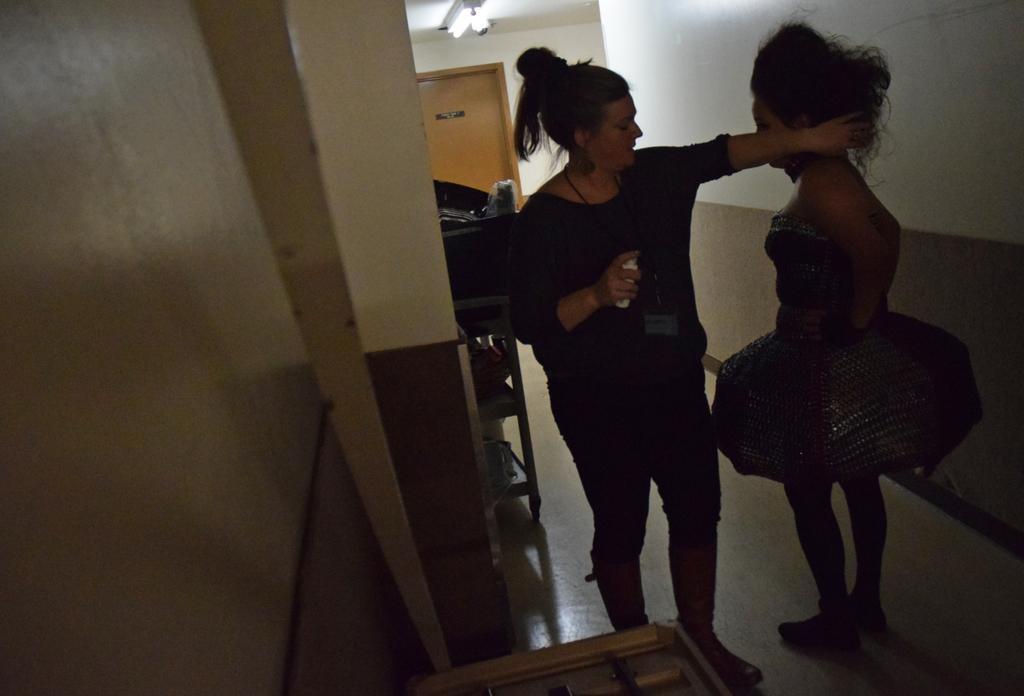Describe this image in one or two sentences. In this picture we can see two women standing on the path. There is a door and a light on top. We can see a wall. 